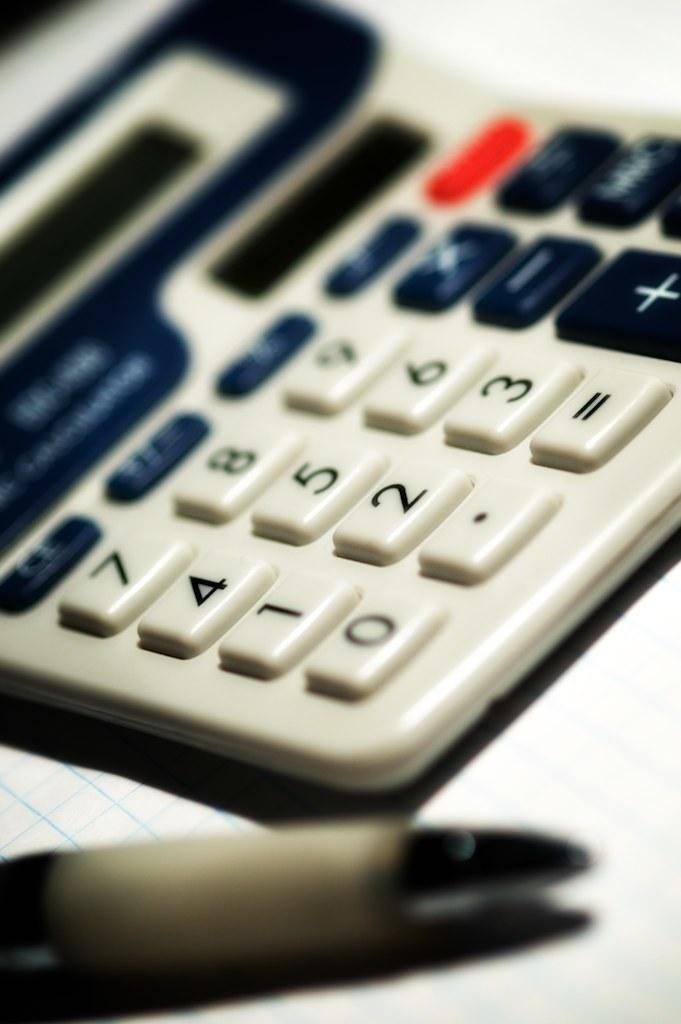Provide a one-sentence caption for the provided image. The four and two on a calculator are visible despite the depth of focus of the image. 